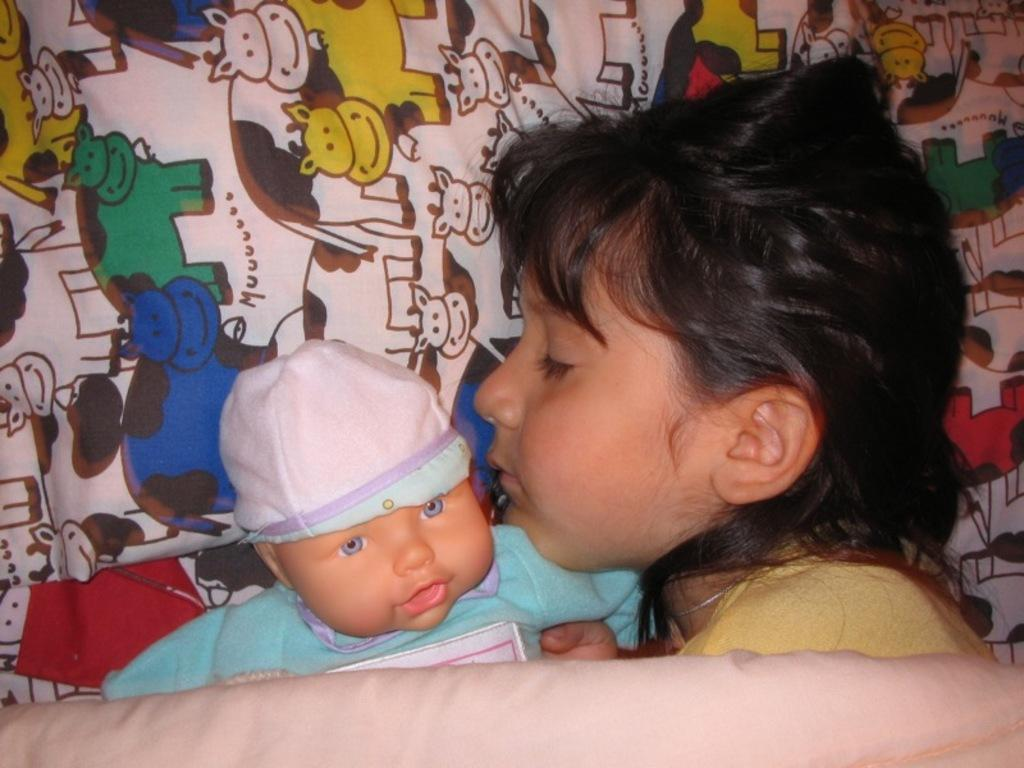Who is the main subject in the image? There is a girl in the image. What is the girl doing in the image? The girl is sleeping on the bed. What object is beside the girl? There is a toy baby beside the girl. What is visible at the bottom of the image? There is a blanket at the bottom of the image. What type of bushes can be seen growing around the girl in the image? There are no bushes visible in the image; it features a girl sleeping on a bed with a toy baby beside her and a blanket at the bottom. 